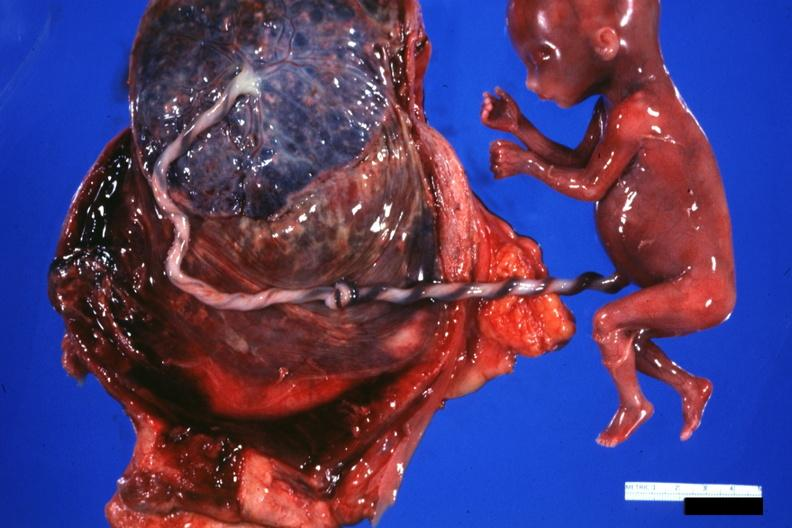does chest and abdomen slide show fetus cord with knot and placenta?
Answer the question using a single word or phrase. No 